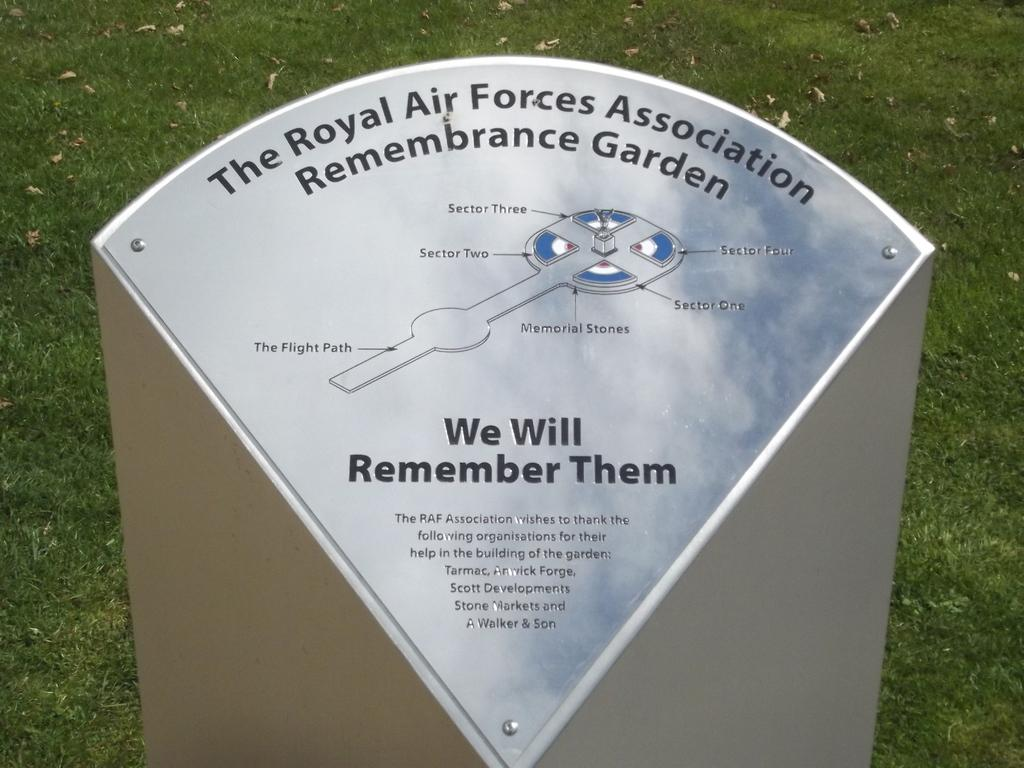What is written on in the image? There is something written on a board in the image. What type of surface is visible in the image? There is grass visible in the image. What type of quiver is present in the image? There is no quiver present in the image. What is inside the jar that can be seen in the image? There is no jar present in the image. 